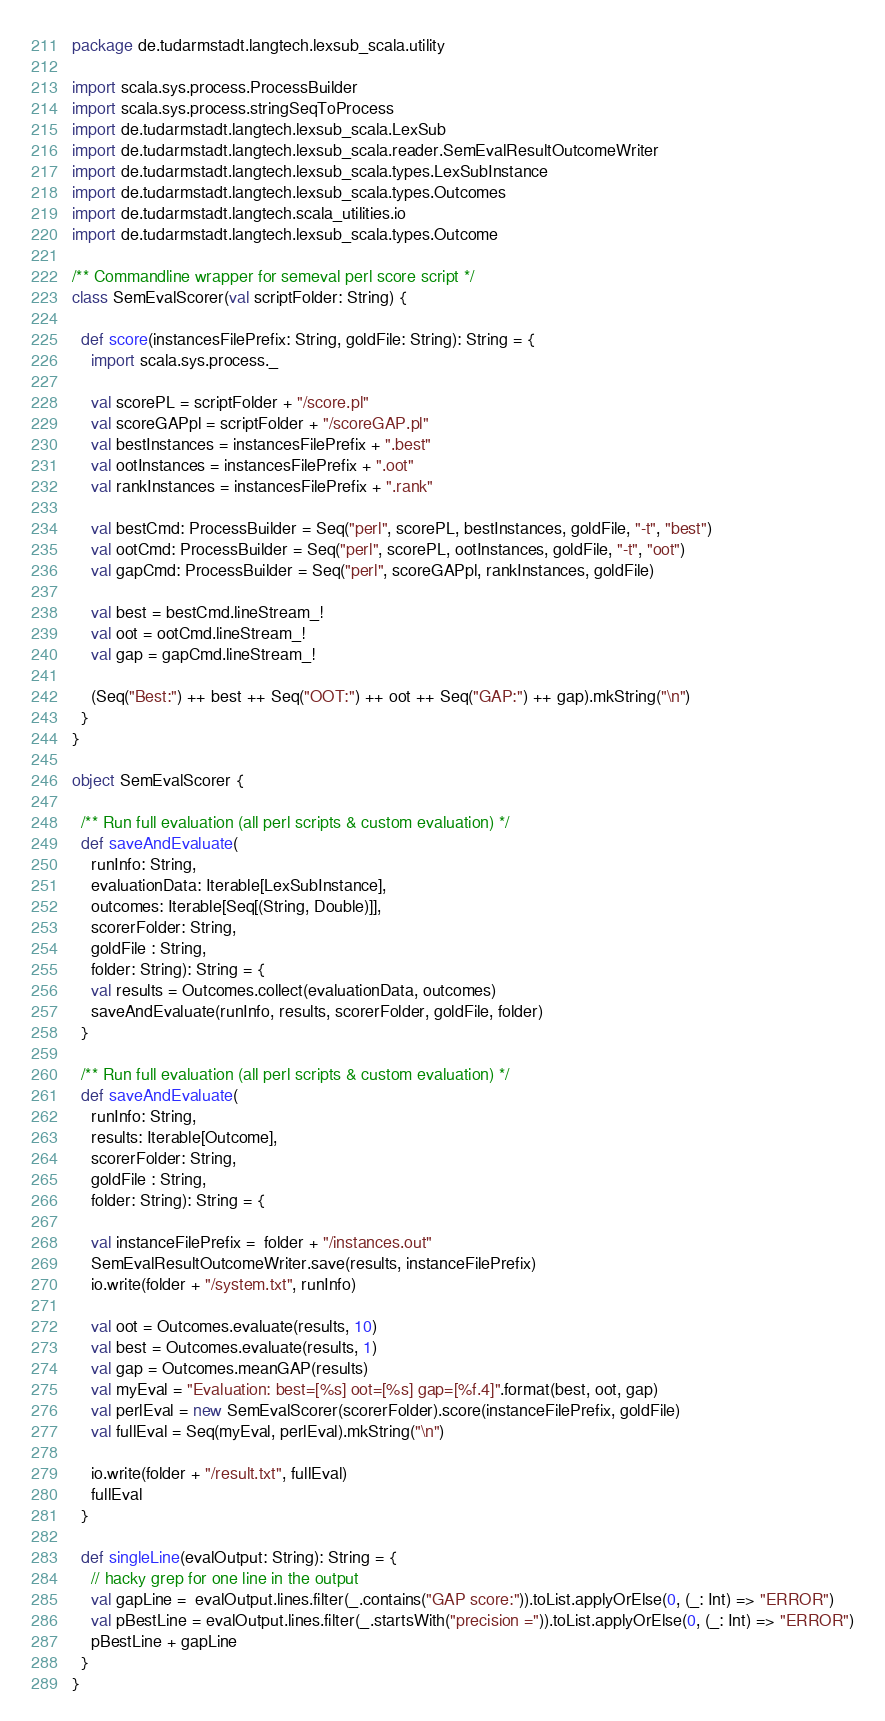<code> <loc_0><loc_0><loc_500><loc_500><_Scala_>package de.tudarmstadt.langtech.lexsub_scala.utility

import scala.sys.process.ProcessBuilder
import scala.sys.process.stringSeqToProcess
import de.tudarmstadt.langtech.lexsub_scala.LexSub
import de.tudarmstadt.langtech.lexsub_scala.reader.SemEvalResultOutcomeWriter
import de.tudarmstadt.langtech.lexsub_scala.types.LexSubInstance
import de.tudarmstadt.langtech.lexsub_scala.types.Outcomes
import de.tudarmstadt.langtech.scala_utilities.io
import de.tudarmstadt.langtech.lexsub_scala.types.Outcome

/** Commandline wrapper for semeval perl score script */
class SemEvalScorer(val scriptFolder: String) {

  def score(instancesFilePrefix: String, goldFile: String): String = {
    import scala.sys.process._

    val scorePL = scriptFolder + "/score.pl"
    val scoreGAPpl = scriptFolder + "/scoreGAP.pl"
    val bestInstances = instancesFilePrefix + ".best"
    val ootInstances = instancesFilePrefix + ".oot"
    val rankInstances = instancesFilePrefix + ".rank"

    val bestCmd: ProcessBuilder = Seq("perl", scorePL, bestInstances, goldFile, "-t", "best")
    val ootCmd: ProcessBuilder = Seq("perl", scorePL, ootInstances, goldFile, "-t", "oot")
    val gapCmd: ProcessBuilder = Seq("perl", scoreGAPpl, rankInstances, goldFile)
    
    val best = bestCmd.lineStream_!
    val oot = ootCmd.lineStream_!
    val gap = gapCmd.lineStream_!

    (Seq("Best:") ++ best ++ Seq("OOT:") ++ oot ++ Seq("GAP:") ++ gap).mkString("\n")
  }
}

object SemEvalScorer {
  
  /** Run full evaluation (all perl scripts & custom evaluation) */
  def saveAndEvaluate(
    runInfo: String,
    evaluationData: Iterable[LexSubInstance],
    outcomes: Iterable[Seq[(String, Double)]],
    scorerFolder: String,
    goldFile : String,
    folder: String): String = {
    val results = Outcomes.collect(evaluationData, outcomes)
    saveAndEvaluate(runInfo, results, scorerFolder, goldFile, folder)
  }
  
  /** Run full evaluation (all perl scripts & custom evaluation) */
  def saveAndEvaluate(
    runInfo: String,
    results: Iterable[Outcome],
    scorerFolder: String,
    goldFile : String,
    folder: String): String = {

    val instanceFilePrefix =  folder + "/instances.out"
    SemEvalResultOutcomeWriter.save(results, instanceFilePrefix)
    io.write(folder + "/system.txt", runInfo)

    val oot = Outcomes.evaluate(results, 10)
    val best = Outcomes.evaluate(results, 1)
    val gap = Outcomes.meanGAP(results)
    val myEval = "Evaluation: best=[%s] oot=[%s] gap=[%f.4]".format(best, oot, gap)
    val perlEval = new SemEvalScorer(scorerFolder).score(instanceFilePrefix, goldFile)
    val fullEval = Seq(myEval, perlEval).mkString("\n")
    
    io.write(folder + "/result.txt", fullEval)
    fullEval
  }
  
  def singleLine(evalOutput: String): String = {
    // hacky grep for one line in the output
    val gapLine =  evalOutput.lines.filter(_.contains("GAP score:")).toList.applyOrElse(0, (_: Int) => "ERROR")
    val pBestLine = evalOutput.lines.filter(_.startsWith("precision =")).toList.applyOrElse(0, (_: Int) => "ERROR")
    pBestLine + gapLine
  }
}</code> 